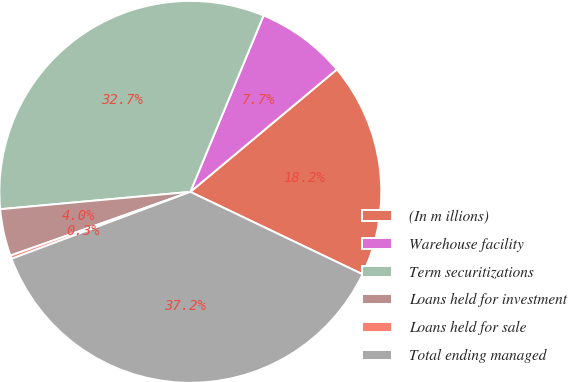Convert chart. <chart><loc_0><loc_0><loc_500><loc_500><pie_chart><fcel>(In m illions)<fcel>Warehouse facility<fcel>Term securitizations<fcel>Loans held for investment<fcel>Loans held for sale<fcel>Total ending managed<nl><fcel>18.18%<fcel>7.66%<fcel>32.71%<fcel>3.97%<fcel>0.28%<fcel>37.2%<nl></chart> 